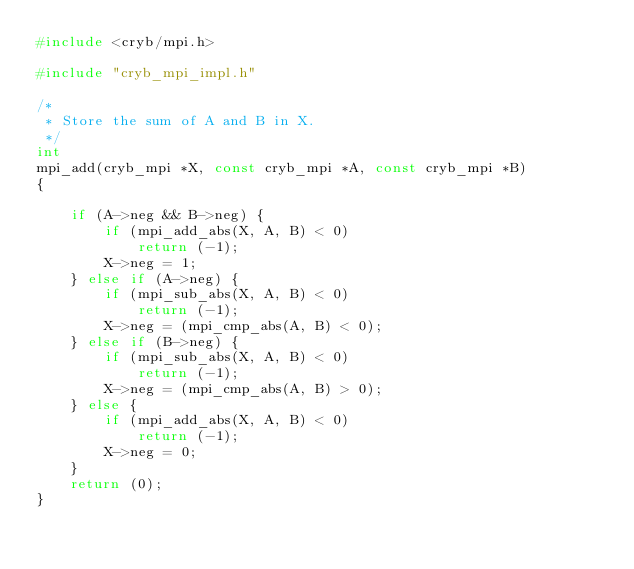<code> <loc_0><loc_0><loc_500><loc_500><_C_>#include <cryb/mpi.h>

#include "cryb_mpi_impl.h"

/*
 * Store the sum of A and B in X.
 */
int
mpi_add(cryb_mpi *X, const cryb_mpi *A, const cryb_mpi *B)
{

	if (A->neg && B->neg) {
		if (mpi_add_abs(X, A, B) < 0)
			return (-1);
		X->neg = 1;
	} else if (A->neg) {
		if (mpi_sub_abs(X, A, B) < 0)
			return (-1);
		X->neg = (mpi_cmp_abs(A, B) < 0);
	} else if (B->neg) {
		if (mpi_sub_abs(X, A, B) < 0)
			return (-1);
		X->neg = (mpi_cmp_abs(A, B) > 0);
	} else {
		if (mpi_add_abs(X, A, B) < 0)
			return (-1);
		X->neg = 0;
	}
	return (0);
}

</code> 